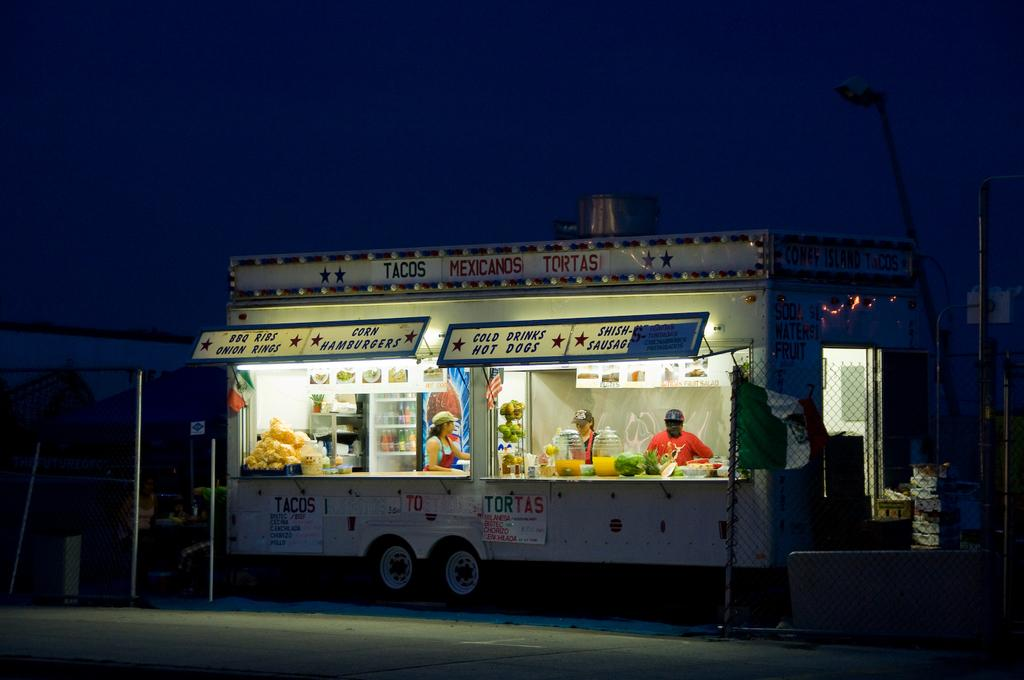What is the main subject of the image? There is a vehicle in the image. What else can be seen in the image besides the vehicle? There are stalls, objects, people, mesh, rods, posters, and a path visible in the image. What is the background of the image? The sky is visible in the background of the image. Can you tell me how many eggs of cow are present in the image? There are no cows or eggs present in the image. What type of drink is being served in the image? The provided facts do not mention any drinks, including eggnog, in the image. 